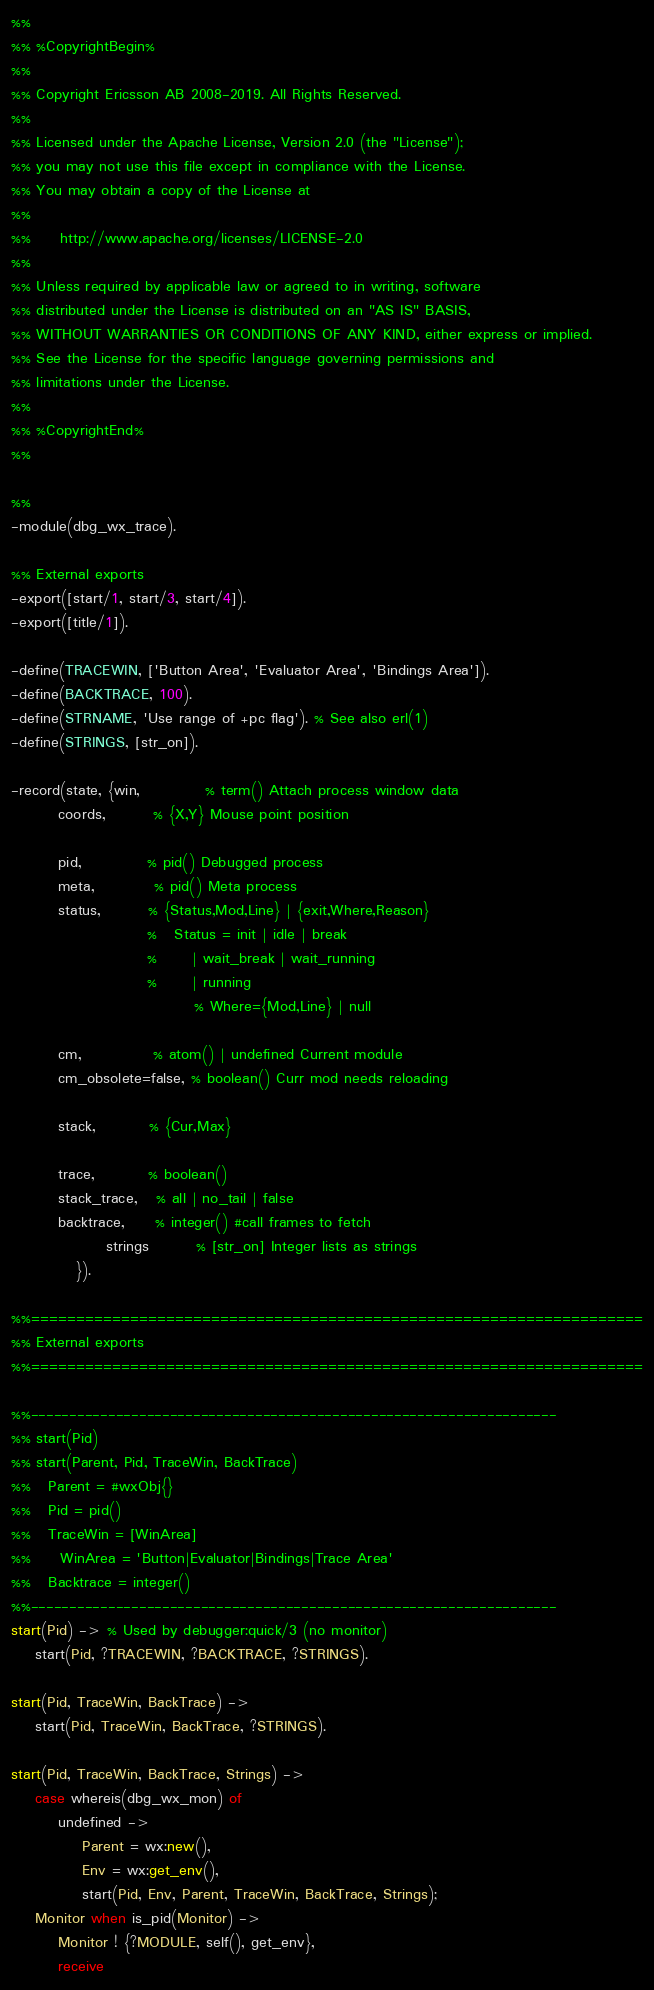<code> <loc_0><loc_0><loc_500><loc_500><_Erlang_>%%
%% %CopyrightBegin%
%% 
%% Copyright Ericsson AB 2008-2019. All Rights Reserved.
%% 
%% Licensed under the Apache License, Version 2.0 (the "License");
%% you may not use this file except in compliance with the License.
%% You may obtain a copy of the License at
%%
%%     http://www.apache.org/licenses/LICENSE-2.0
%%
%% Unless required by applicable law or agreed to in writing, software
%% distributed under the License is distributed on an "AS IS" BASIS,
%% WITHOUT WARRANTIES OR CONDITIONS OF ANY KIND, either express or implied.
%% See the License for the specific language governing permissions and
%% limitations under the License.
%% 
%% %CopyrightEnd%
%%

%%
-module(dbg_wx_trace).

%% External exports
-export([start/1, start/3, start/4]).
-export([title/1]).

-define(TRACEWIN, ['Button Area', 'Evaluator Area', 'Bindings Area']).
-define(BACKTRACE, 100).
-define(STRNAME, 'Use range of +pc flag'). % See also erl(1)
-define(STRINGS, [str_on]).

-record(state, {win,           % term() Attach process window data
		coords,        % {X,Y} Mouse point position

		pid,           % pid() Debugged process
		meta,          % pid() Meta process
		status,        % {Status,Mod,Line} | {exit,Where,Reason}
		               %   Status = init | idle | break
		               %      | wait_break | wait_running
		               %      | running
                               % Where={Mod,Line} | null

		cm,            % atom() | undefined Current module
		cm_obsolete=false, % boolean() Curr mod needs reloading

		stack,         % {Cur,Max}

		trace,         % boolean()
		stack_trace,   % all | no_tail | false
		backtrace,     % integer() #call frames to fetch
                strings        % [str_on] Integer lists as strings
	       }).

%%====================================================================
%% External exports
%%====================================================================

%%--------------------------------------------------------------------
%% start(Pid)
%% start(Parent, Pid, TraceWin, BackTrace)
%%   Parent = #wxObj{}
%%   Pid = pid()
%%   TraceWin = [WinArea]
%%     WinArea = 'Button|Evaluator|Bindings|Trace Area'
%%   Backtrace = integer()
%%--------------------------------------------------------------------
start(Pid) -> % Used by debugger:quick/3 (no monitor)    
    start(Pid, ?TRACEWIN, ?BACKTRACE, ?STRINGS).

start(Pid, TraceWin, BackTrace) ->
    start(Pid, TraceWin, BackTrace, ?STRINGS).

start(Pid, TraceWin, BackTrace, Strings) ->
    case whereis(dbg_wx_mon) of
        undefined ->
            Parent = wx:new(),
            Env = wx:get_env(),
            start(Pid, Env, Parent, TraceWin, BackTrace, Strings);
	Monitor when is_pid(Monitor) ->
	    Monitor ! {?MODULE, self(), get_env},
	    receive</code> 